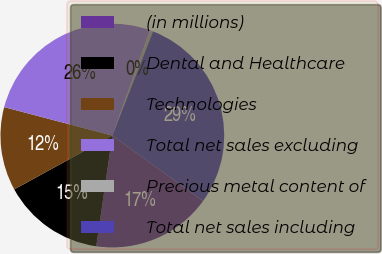<chart> <loc_0><loc_0><loc_500><loc_500><pie_chart><fcel>(in millions)<fcel>Dental and Healthcare<fcel>Technologies<fcel>Total net sales excluding<fcel>Precious metal content of<fcel>Total net sales including<nl><fcel>17.36%<fcel>14.72%<fcel>12.08%<fcel>26.37%<fcel>0.46%<fcel>29.01%<nl></chart> 